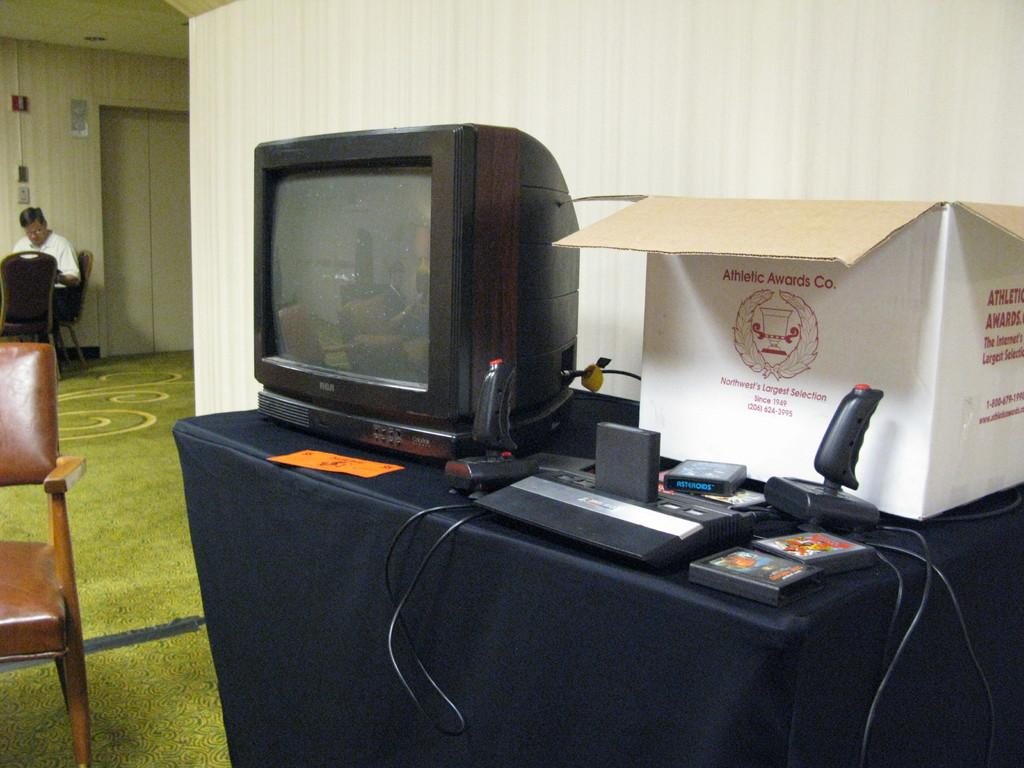<image>
Present a compact description of the photo's key features. The white box sitting beside the computer has Athletic Awards Co written on it. 